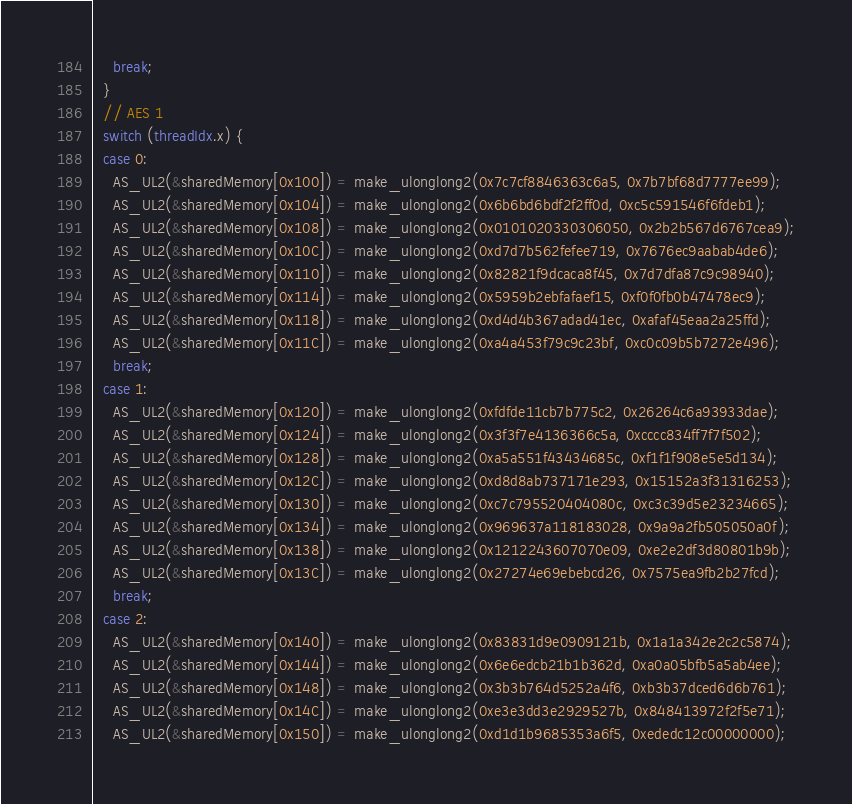Convert code to text. <code><loc_0><loc_0><loc_500><loc_500><_Cuda_>    break;
  }
  // AES 1
  switch (threadIdx.x) {
  case 0:
    AS_UL2(&sharedMemory[0x100]) = make_ulonglong2(0x7c7cf8846363c6a5, 0x7b7bf68d7777ee99);
    AS_UL2(&sharedMemory[0x104]) = make_ulonglong2(0x6b6bd6bdf2f2ff0d, 0xc5c591546f6fdeb1);
    AS_UL2(&sharedMemory[0x108]) = make_ulonglong2(0x0101020330306050, 0x2b2b567d6767cea9);
    AS_UL2(&sharedMemory[0x10C]) = make_ulonglong2(0xd7d7b562fefee719, 0x7676ec9aabab4de6);
    AS_UL2(&sharedMemory[0x110]) = make_ulonglong2(0x82821f9dcaca8f45, 0x7d7dfa87c9c98940);
    AS_UL2(&sharedMemory[0x114]) = make_ulonglong2(0x5959b2ebfafaef15, 0xf0f0fb0b47478ec9);
    AS_UL2(&sharedMemory[0x118]) = make_ulonglong2(0xd4d4b367adad41ec, 0xafaf45eaa2a25ffd);
    AS_UL2(&sharedMemory[0x11C]) = make_ulonglong2(0xa4a453f79c9c23bf, 0xc0c09b5b7272e496);
    break;
  case 1:
    AS_UL2(&sharedMemory[0x120]) = make_ulonglong2(0xfdfde11cb7b775c2, 0x26264c6a93933dae);
    AS_UL2(&sharedMemory[0x124]) = make_ulonglong2(0x3f3f7e4136366c5a, 0xcccc834ff7f7f502);
    AS_UL2(&sharedMemory[0x128]) = make_ulonglong2(0xa5a551f43434685c, 0xf1f1f908e5e5d134);
    AS_UL2(&sharedMemory[0x12C]) = make_ulonglong2(0xd8d8ab737171e293, 0x15152a3f31316253);
    AS_UL2(&sharedMemory[0x130]) = make_ulonglong2(0xc7c795520404080c, 0xc3c39d5e23234665);
    AS_UL2(&sharedMemory[0x134]) = make_ulonglong2(0x969637a118183028, 0x9a9a2fb505050a0f);
    AS_UL2(&sharedMemory[0x138]) = make_ulonglong2(0x1212243607070e09, 0xe2e2df3d80801b9b);
    AS_UL2(&sharedMemory[0x13C]) = make_ulonglong2(0x27274e69ebebcd26, 0x7575ea9fb2b27fcd);
    break;
  case 2:
    AS_UL2(&sharedMemory[0x140]) = make_ulonglong2(0x83831d9e0909121b, 0x1a1a342e2c2c5874);
    AS_UL2(&sharedMemory[0x144]) = make_ulonglong2(0x6e6edcb21b1b362d, 0xa0a05bfb5a5ab4ee);
    AS_UL2(&sharedMemory[0x148]) = make_ulonglong2(0x3b3b764d5252a4f6, 0xb3b37dced6d6b761);
    AS_UL2(&sharedMemory[0x14C]) = make_ulonglong2(0xe3e3dd3e2929527b, 0x848413972f2f5e71);
    AS_UL2(&sharedMemory[0x150]) = make_ulonglong2(0xd1d1b9685353a6f5, 0xededc12c00000000);</code> 